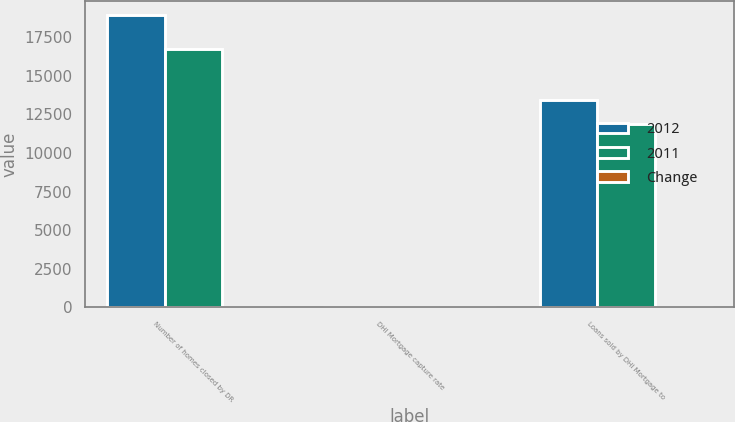Convert chart to OTSL. <chart><loc_0><loc_0><loc_500><loc_500><stacked_bar_chart><ecel><fcel>Number of homes closed by DR<fcel>DHI Mortgage capture rate<fcel>Loans sold by DHI Mortgage to<nl><fcel>2012<fcel>18890<fcel>59<fcel>13397<nl><fcel>2011<fcel>16695<fcel>61<fcel>11888<nl><fcel>Change<fcel>9<fcel>13<fcel>13<nl></chart> 